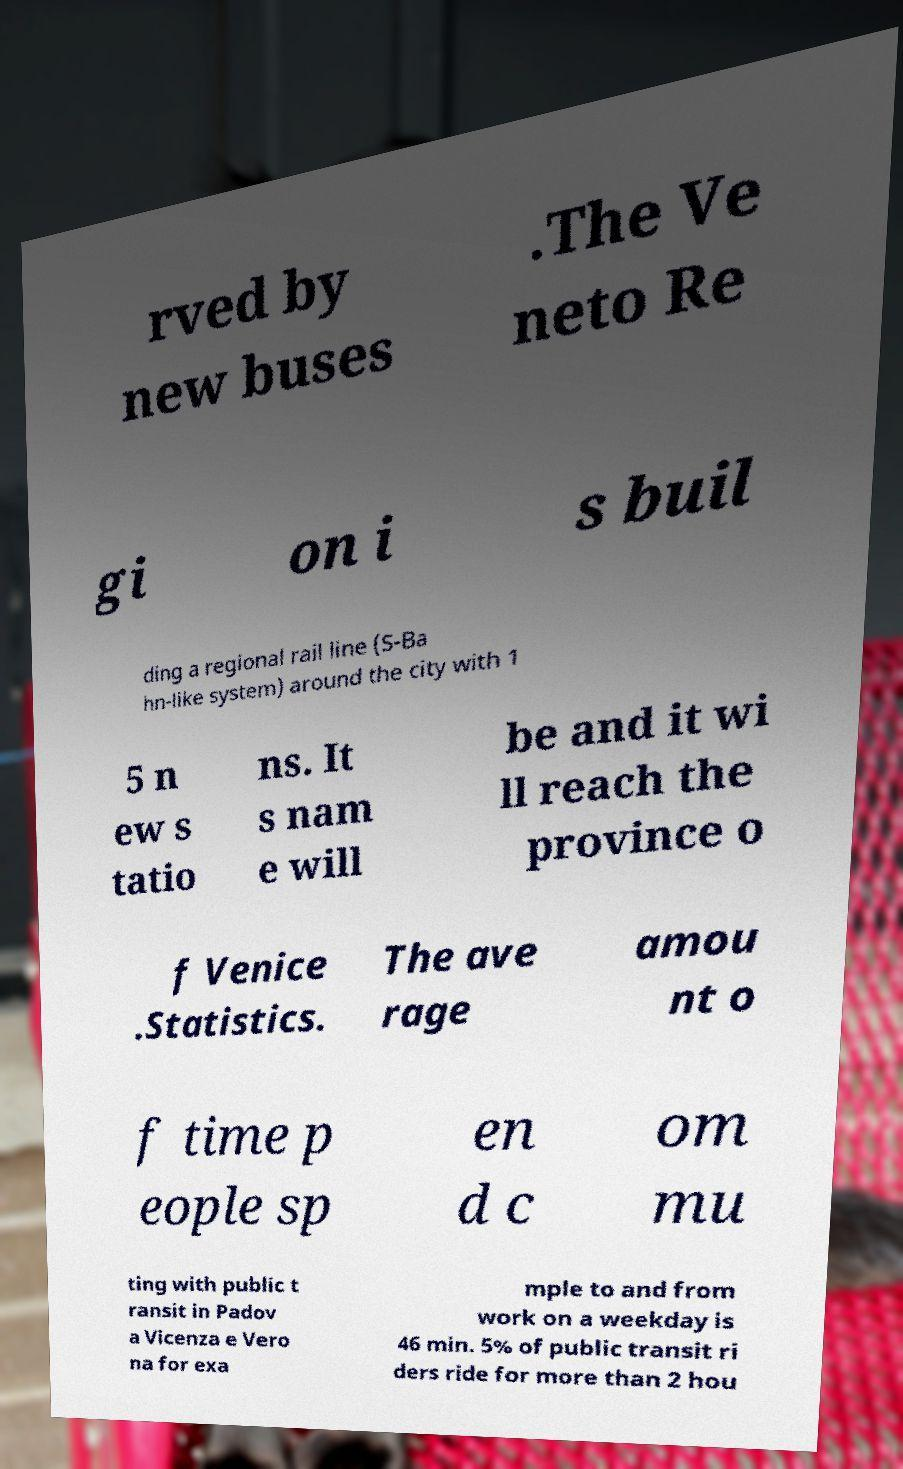There's text embedded in this image that I need extracted. Can you transcribe it verbatim? rved by new buses .The Ve neto Re gi on i s buil ding a regional rail line (S-Ba hn-like system) around the city with 1 5 n ew s tatio ns. It s nam e will be and it wi ll reach the province o f Venice .Statistics. The ave rage amou nt o f time p eople sp en d c om mu ting with public t ransit in Padov a Vicenza e Vero na for exa mple to and from work on a weekday is 46 min. 5% of public transit ri ders ride for more than 2 hou 